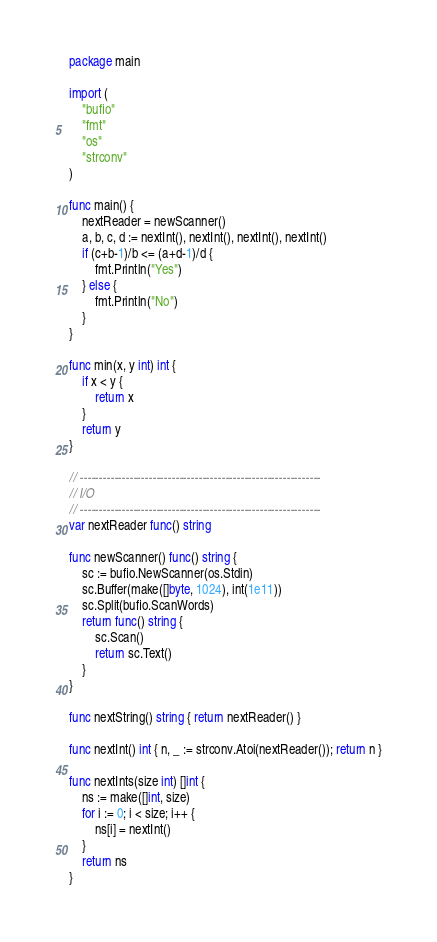<code> <loc_0><loc_0><loc_500><loc_500><_Go_>package main

import (
	"bufio"
	"fmt"
	"os"
	"strconv"
)

func main() {
	nextReader = newScanner()
	a, b, c, d := nextInt(), nextInt(), nextInt(), nextInt()
	if (c+b-1)/b <= (a+d-1)/d {
		fmt.Println("Yes")
	} else {
		fmt.Println("No")
	}
}

func min(x, y int) int {
	if x < y {
		return x
	}
	return y
}

// ---------------------------------------------------------------
// I/O
// ---------------------------------------------------------------
var nextReader func() string

func newScanner() func() string {
	sc := bufio.NewScanner(os.Stdin)
	sc.Buffer(make([]byte, 1024), int(1e11))
	sc.Split(bufio.ScanWords)
	return func() string {
		sc.Scan()
		return sc.Text()
	}
}

func nextString() string { return nextReader() }

func nextInt() int { n, _ := strconv.Atoi(nextReader()); return n }

func nextInts(size int) []int {
	ns := make([]int, size)
	for i := 0; i < size; i++ {
		ns[i] = nextInt()
	}
	return ns
}
</code> 